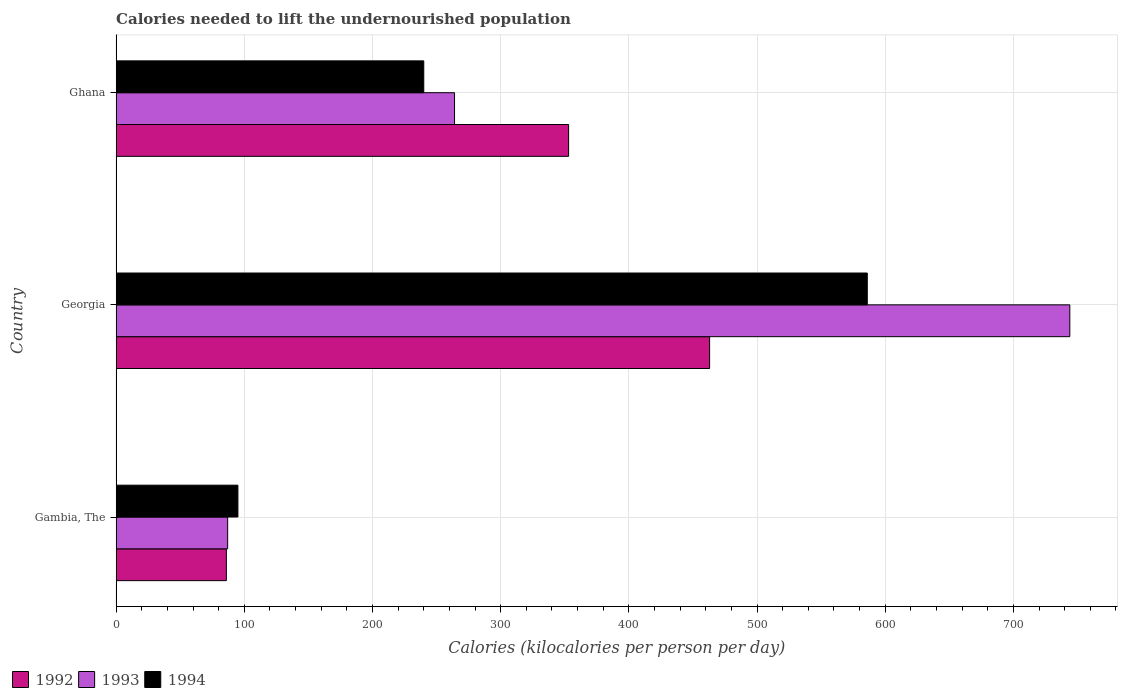Are the number of bars on each tick of the Y-axis equal?
Your answer should be very brief. Yes. What is the label of the 2nd group of bars from the top?
Give a very brief answer. Georgia. What is the total calories needed to lift the undernourished population in 1993 in Ghana?
Offer a very short reply. 264. Across all countries, what is the maximum total calories needed to lift the undernourished population in 1993?
Provide a short and direct response. 744. In which country was the total calories needed to lift the undernourished population in 1994 maximum?
Your response must be concise. Georgia. In which country was the total calories needed to lift the undernourished population in 1994 minimum?
Ensure brevity in your answer.  Gambia, The. What is the total total calories needed to lift the undernourished population in 1994 in the graph?
Offer a terse response. 921. What is the difference between the total calories needed to lift the undernourished population in 1992 in Gambia, The and that in Ghana?
Your answer should be compact. -267. What is the difference between the total calories needed to lift the undernourished population in 1992 in Gambia, The and the total calories needed to lift the undernourished population in 1994 in Georgia?
Provide a short and direct response. -500. What is the average total calories needed to lift the undernourished population in 1994 per country?
Provide a short and direct response. 307. What is the difference between the total calories needed to lift the undernourished population in 1992 and total calories needed to lift the undernourished population in 1994 in Georgia?
Offer a terse response. -123. What is the ratio of the total calories needed to lift the undernourished population in 1992 in Gambia, The to that in Georgia?
Provide a short and direct response. 0.19. What is the difference between the highest and the second highest total calories needed to lift the undernourished population in 1993?
Your answer should be very brief. 480. What is the difference between the highest and the lowest total calories needed to lift the undernourished population in 1993?
Provide a succinct answer. 657. Is the sum of the total calories needed to lift the undernourished population in 1993 in Gambia, The and Ghana greater than the maximum total calories needed to lift the undernourished population in 1992 across all countries?
Keep it short and to the point. No. What does the 1st bar from the bottom in Ghana represents?
Offer a very short reply. 1992. Is it the case that in every country, the sum of the total calories needed to lift the undernourished population in 1994 and total calories needed to lift the undernourished population in 1993 is greater than the total calories needed to lift the undernourished population in 1992?
Provide a short and direct response. Yes. How many bars are there?
Provide a short and direct response. 9. What is the difference between two consecutive major ticks on the X-axis?
Ensure brevity in your answer.  100. Are the values on the major ticks of X-axis written in scientific E-notation?
Offer a very short reply. No. Does the graph contain grids?
Provide a short and direct response. Yes. Where does the legend appear in the graph?
Make the answer very short. Bottom left. What is the title of the graph?
Ensure brevity in your answer.  Calories needed to lift the undernourished population. What is the label or title of the X-axis?
Provide a short and direct response. Calories (kilocalories per person per day). What is the Calories (kilocalories per person per day) of 1994 in Gambia, The?
Provide a succinct answer. 95. What is the Calories (kilocalories per person per day) of 1992 in Georgia?
Give a very brief answer. 463. What is the Calories (kilocalories per person per day) of 1993 in Georgia?
Provide a short and direct response. 744. What is the Calories (kilocalories per person per day) in 1994 in Georgia?
Ensure brevity in your answer.  586. What is the Calories (kilocalories per person per day) in 1992 in Ghana?
Make the answer very short. 353. What is the Calories (kilocalories per person per day) in 1993 in Ghana?
Offer a terse response. 264. What is the Calories (kilocalories per person per day) in 1994 in Ghana?
Make the answer very short. 240. Across all countries, what is the maximum Calories (kilocalories per person per day) in 1992?
Keep it short and to the point. 463. Across all countries, what is the maximum Calories (kilocalories per person per day) of 1993?
Provide a succinct answer. 744. Across all countries, what is the maximum Calories (kilocalories per person per day) in 1994?
Offer a very short reply. 586. What is the total Calories (kilocalories per person per day) in 1992 in the graph?
Offer a very short reply. 902. What is the total Calories (kilocalories per person per day) in 1993 in the graph?
Provide a succinct answer. 1095. What is the total Calories (kilocalories per person per day) in 1994 in the graph?
Give a very brief answer. 921. What is the difference between the Calories (kilocalories per person per day) of 1992 in Gambia, The and that in Georgia?
Your answer should be very brief. -377. What is the difference between the Calories (kilocalories per person per day) in 1993 in Gambia, The and that in Georgia?
Offer a very short reply. -657. What is the difference between the Calories (kilocalories per person per day) of 1994 in Gambia, The and that in Georgia?
Ensure brevity in your answer.  -491. What is the difference between the Calories (kilocalories per person per day) of 1992 in Gambia, The and that in Ghana?
Provide a succinct answer. -267. What is the difference between the Calories (kilocalories per person per day) in 1993 in Gambia, The and that in Ghana?
Provide a short and direct response. -177. What is the difference between the Calories (kilocalories per person per day) of 1994 in Gambia, The and that in Ghana?
Keep it short and to the point. -145. What is the difference between the Calories (kilocalories per person per day) of 1992 in Georgia and that in Ghana?
Make the answer very short. 110. What is the difference between the Calories (kilocalories per person per day) in 1993 in Georgia and that in Ghana?
Provide a succinct answer. 480. What is the difference between the Calories (kilocalories per person per day) in 1994 in Georgia and that in Ghana?
Your response must be concise. 346. What is the difference between the Calories (kilocalories per person per day) in 1992 in Gambia, The and the Calories (kilocalories per person per day) in 1993 in Georgia?
Offer a terse response. -658. What is the difference between the Calories (kilocalories per person per day) in 1992 in Gambia, The and the Calories (kilocalories per person per day) in 1994 in Georgia?
Your answer should be very brief. -500. What is the difference between the Calories (kilocalories per person per day) in 1993 in Gambia, The and the Calories (kilocalories per person per day) in 1994 in Georgia?
Provide a succinct answer. -499. What is the difference between the Calories (kilocalories per person per day) of 1992 in Gambia, The and the Calories (kilocalories per person per day) of 1993 in Ghana?
Your answer should be compact. -178. What is the difference between the Calories (kilocalories per person per day) in 1992 in Gambia, The and the Calories (kilocalories per person per day) in 1994 in Ghana?
Provide a succinct answer. -154. What is the difference between the Calories (kilocalories per person per day) of 1993 in Gambia, The and the Calories (kilocalories per person per day) of 1994 in Ghana?
Ensure brevity in your answer.  -153. What is the difference between the Calories (kilocalories per person per day) in 1992 in Georgia and the Calories (kilocalories per person per day) in 1993 in Ghana?
Your answer should be compact. 199. What is the difference between the Calories (kilocalories per person per day) of 1992 in Georgia and the Calories (kilocalories per person per day) of 1994 in Ghana?
Your answer should be compact. 223. What is the difference between the Calories (kilocalories per person per day) in 1993 in Georgia and the Calories (kilocalories per person per day) in 1994 in Ghana?
Offer a very short reply. 504. What is the average Calories (kilocalories per person per day) of 1992 per country?
Ensure brevity in your answer.  300.67. What is the average Calories (kilocalories per person per day) in 1993 per country?
Ensure brevity in your answer.  365. What is the average Calories (kilocalories per person per day) of 1994 per country?
Your answer should be compact. 307. What is the difference between the Calories (kilocalories per person per day) of 1992 and Calories (kilocalories per person per day) of 1994 in Gambia, The?
Your answer should be compact. -9. What is the difference between the Calories (kilocalories per person per day) in 1993 and Calories (kilocalories per person per day) in 1994 in Gambia, The?
Provide a succinct answer. -8. What is the difference between the Calories (kilocalories per person per day) of 1992 and Calories (kilocalories per person per day) of 1993 in Georgia?
Make the answer very short. -281. What is the difference between the Calories (kilocalories per person per day) in 1992 and Calories (kilocalories per person per day) in 1994 in Georgia?
Ensure brevity in your answer.  -123. What is the difference between the Calories (kilocalories per person per day) of 1993 and Calories (kilocalories per person per day) of 1994 in Georgia?
Offer a terse response. 158. What is the difference between the Calories (kilocalories per person per day) in 1992 and Calories (kilocalories per person per day) in 1993 in Ghana?
Offer a terse response. 89. What is the difference between the Calories (kilocalories per person per day) of 1992 and Calories (kilocalories per person per day) of 1994 in Ghana?
Your answer should be compact. 113. What is the ratio of the Calories (kilocalories per person per day) in 1992 in Gambia, The to that in Georgia?
Provide a succinct answer. 0.19. What is the ratio of the Calories (kilocalories per person per day) in 1993 in Gambia, The to that in Georgia?
Your answer should be compact. 0.12. What is the ratio of the Calories (kilocalories per person per day) in 1994 in Gambia, The to that in Georgia?
Your answer should be compact. 0.16. What is the ratio of the Calories (kilocalories per person per day) in 1992 in Gambia, The to that in Ghana?
Give a very brief answer. 0.24. What is the ratio of the Calories (kilocalories per person per day) of 1993 in Gambia, The to that in Ghana?
Ensure brevity in your answer.  0.33. What is the ratio of the Calories (kilocalories per person per day) in 1994 in Gambia, The to that in Ghana?
Provide a succinct answer. 0.4. What is the ratio of the Calories (kilocalories per person per day) of 1992 in Georgia to that in Ghana?
Offer a terse response. 1.31. What is the ratio of the Calories (kilocalories per person per day) in 1993 in Georgia to that in Ghana?
Make the answer very short. 2.82. What is the ratio of the Calories (kilocalories per person per day) in 1994 in Georgia to that in Ghana?
Provide a succinct answer. 2.44. What is the difference between the highest and the second highest Calories (kilocalories per person per day) in 1992?
Your answer should be very brief. 110. What is the difference between the highest and the second highest Calories (kilocalories per person per day) of 1993?
Make the answer very short. 480. What is the difference between the highest and the second highest Calories (kilocalories per person per day) of 1994?
Keep it short and to the point. 346. What is the difference between the highest and the lowest Calories (kilocalories per person per day) in 1992?
Provide a short and direct response. 377. What is the difference between the highest and the lowest Calories (kilocalories per person per day) in 1993?
Your response must be concise. 657. What is the difference between the highest and the lowest Calories (kilocalories per person per day) in 1994?
Provide a short and direct response. 491. 